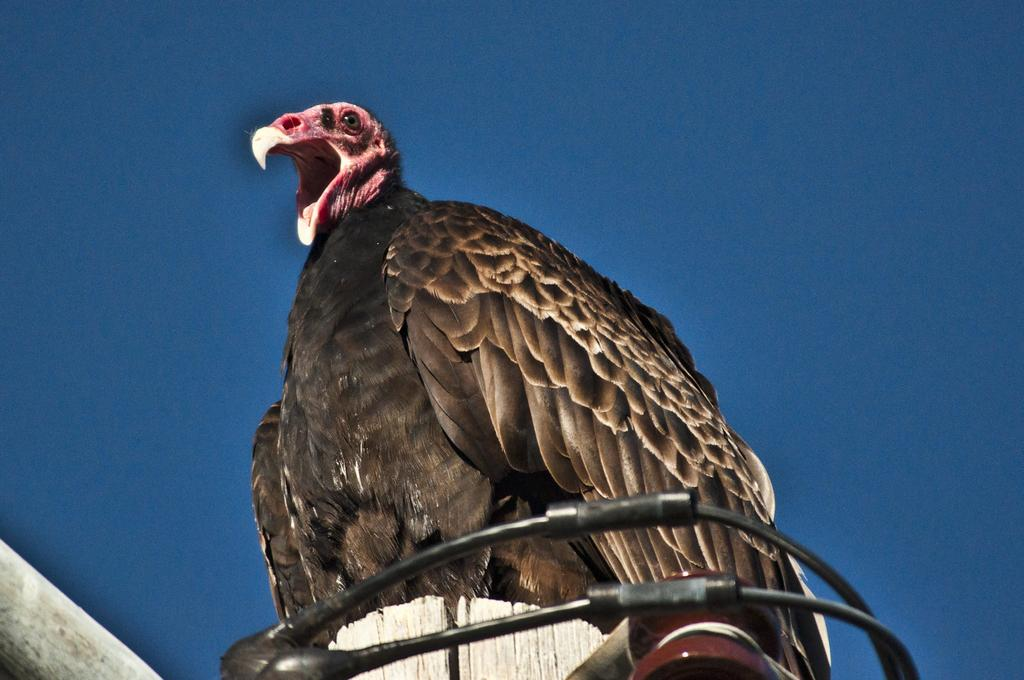What type of bird is in the image? There is a vulture in the image. What is the vulture standing on? The vulture is standing on a plastic pipe. What is visible at the top of the image? The sky is visible at the top of the image. Where is the square jewel located in the image? There is no square jewel present in the image. What type of lumber is being used to build the structure in the image? There is no structure or lumber present in the image; it features a vulture standing on a plastic pipe. 